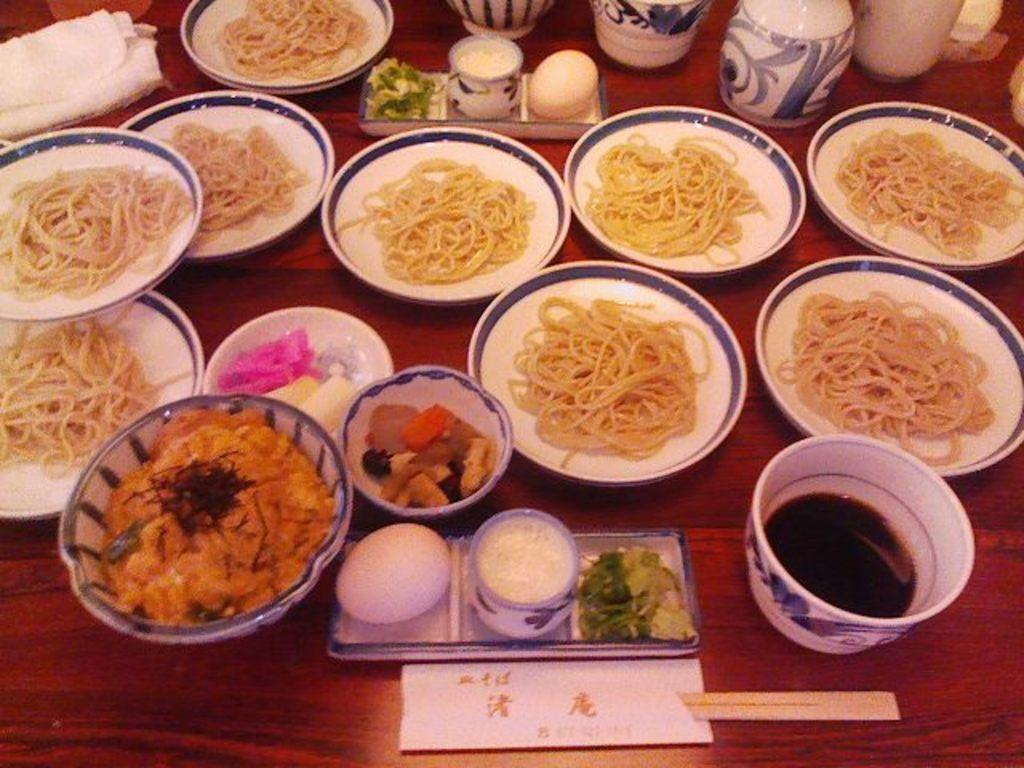What type of surface is visible in the image? There is a wooden surface in the image. What objects are placed on the wooden surface? There are plates and bowls on the wooden surface. What is on the plates? There is food on the plates. Are there any other items visible on the wooden surface besides plates and bowls? The fact sheet does not mention any other items, so we cannot definitively answer that question. How many hands are visible in the image? There are no hands visible in the image. What type of corn is being served on the plates? There is no corn visible on the plates in the image. 